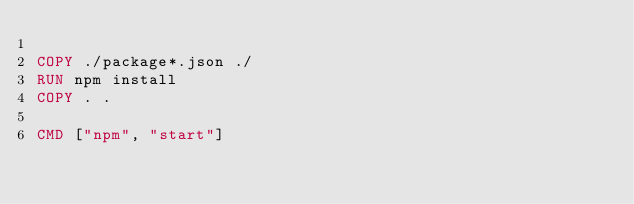<code> <loc_0><loc_0><loc_500><loc_500><_Dockerfile_>
COPY ./package*.json ./
RUN npm install
COPY . .

CMD ["npm", "start"]</code> 